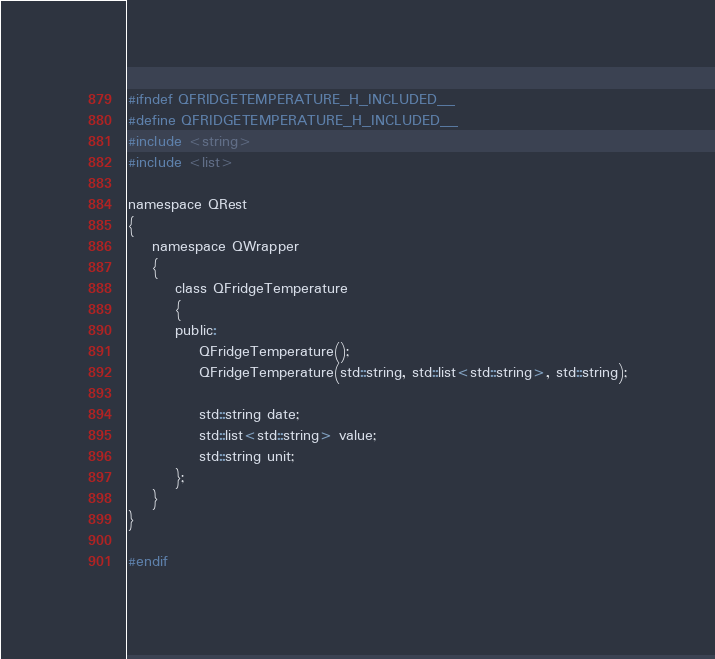<code> <loc_0><loc_0><loc_500><loc_500><_C_>#ifndef QFRIDGETEMPERATURE_H_INCLUDED__
#define QFRIDGETEMPERATURE_H_INCLUDED__
#include <string>
#include <list>

namespace QRest
{
	namespace QWrapper
	{
		class QFridgeTemperature
		{
		public:
			QFridgeTemperature();
			QFridgeTemperature(std::string, std::list<std::string>, std::string);

			std::string date;
			std::list<std::string> value;
			std::string unit;
		};
	}
}

#endif</code> 